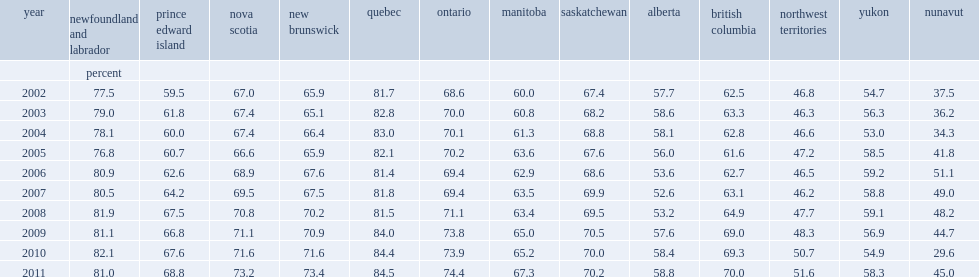What is the percentage of interprovincial employees from quebec drawing on average of their annual wages and salaries from work done outside their province from 2002 to 2011? 82.72. What is the percentage of interprovincial employees from newfoundland and labrador drawing on average of their annual wages and salaries from work done outside their province from 2002 to 2011? 79.89. 